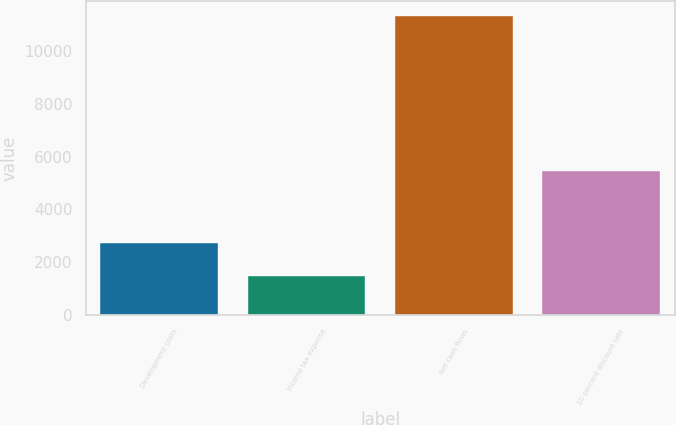Convert chart to OTSL. <chart><loc_0><loc_0><loc_500><loc_500><bar_chart><fcel>Development costs<fcel>Income tax expense<fcel>Net cash flows<fcel>10 percent discount rate<nl><fcel>2736<fcel>1464<fcel>11331<fcel>5446<nl></chart> 